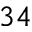Convert formula to latex. <formula><loc_0><loc_0><loc_500><loc_500>^ { 3 4 }</formula> 